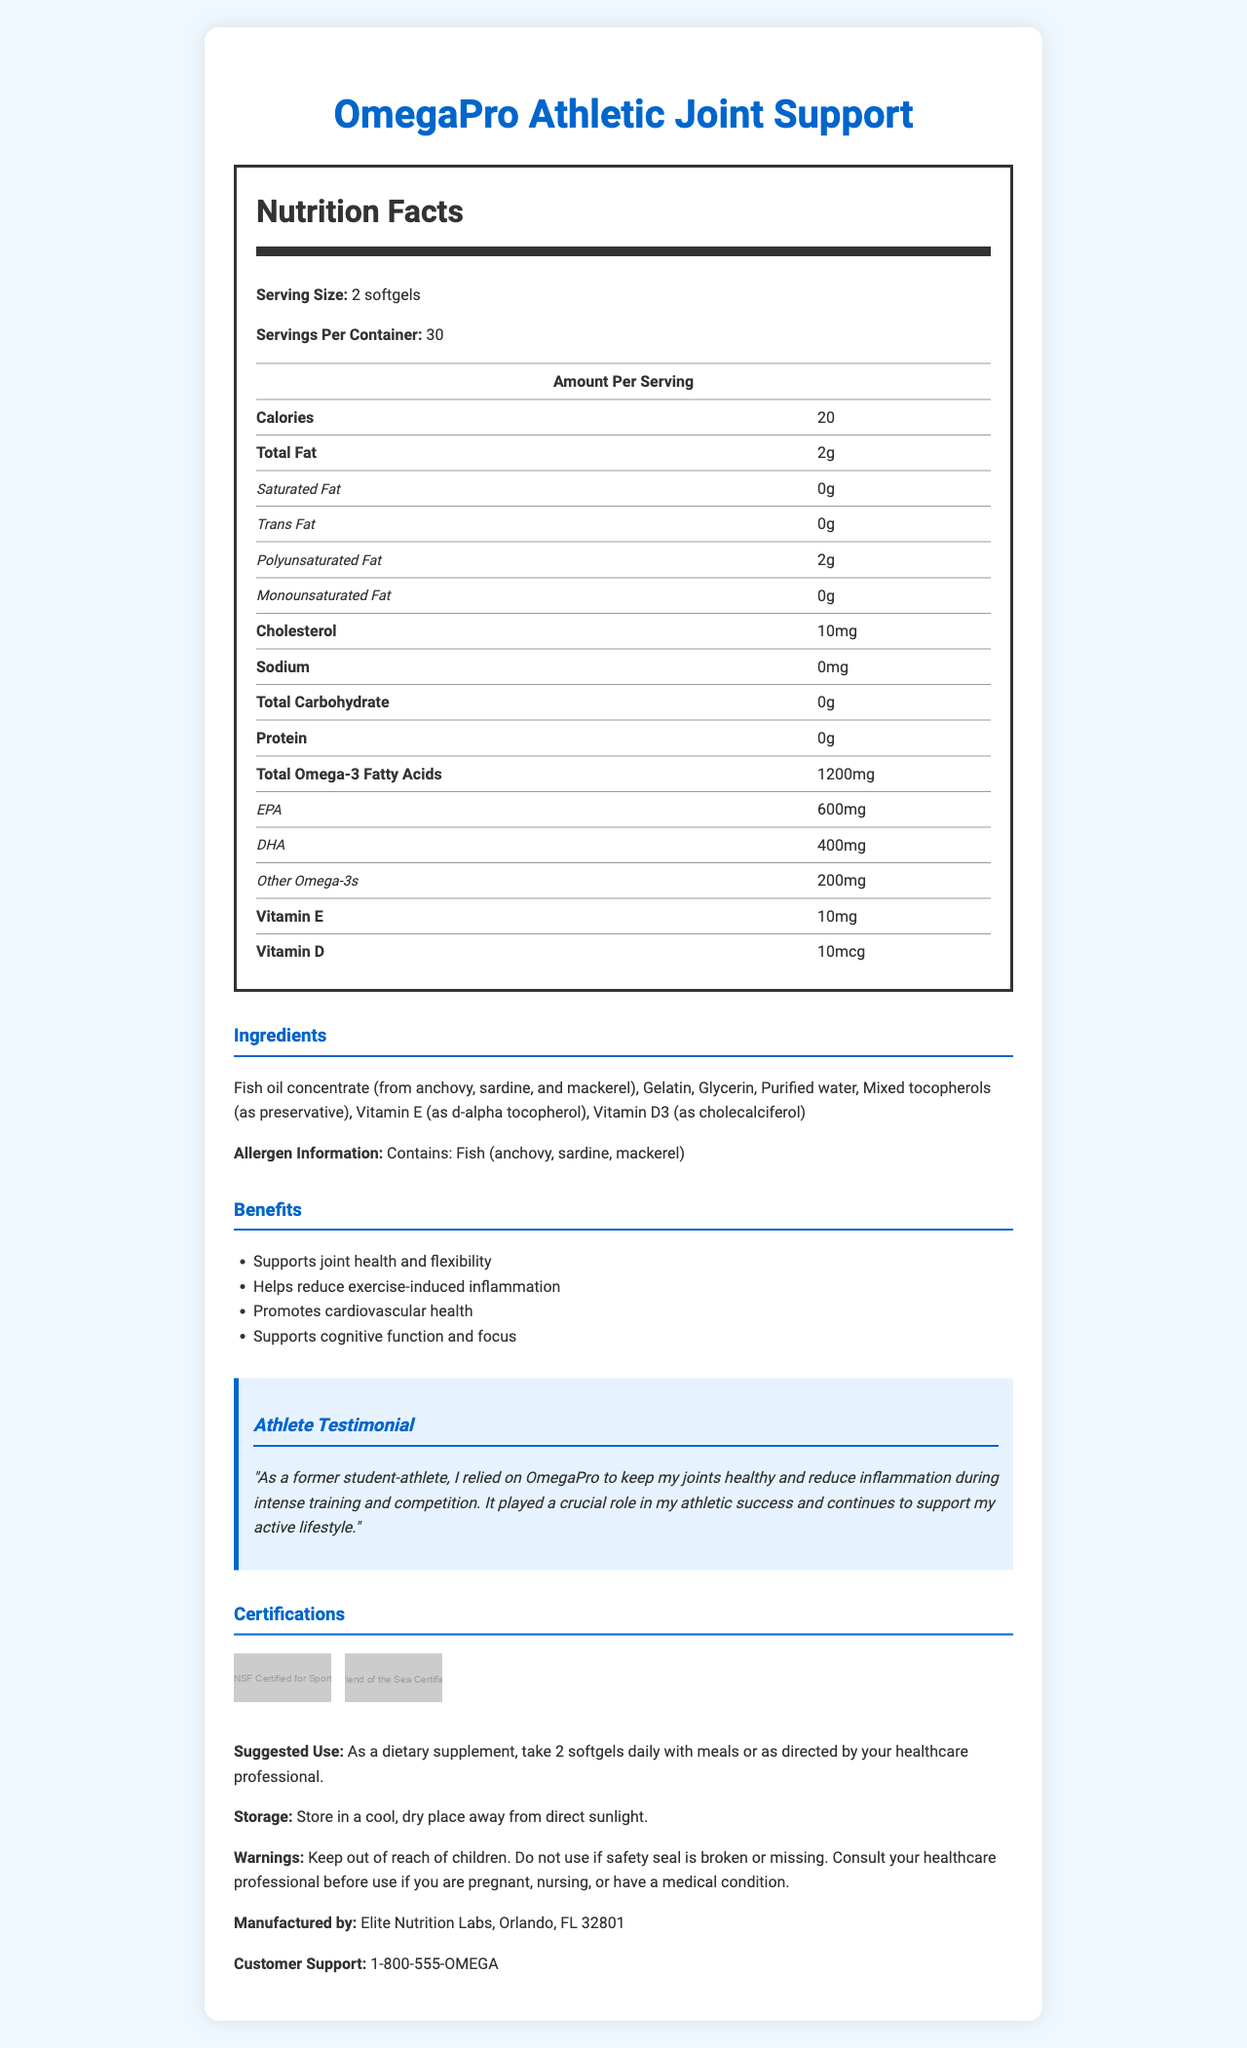who manufactures OmegaPro Athletic Joint Support? The document states that OmegaPro Athletic Joint Support is manufactured by Elite Nutrition Labs in Orlando, FL.
Answer: Elite Nutrition Labs what is the serving size for OmegaPro Athletic Joint Support? The serving size is mentioned as 2 softgels in the document.
Answer: 2 softgels how many calories are in one serving? The document states that each serving of 2 softgels contains 20 calories.
Answer: 20 what is the total omega-3 fatty acid content per serving? The total omega-3 fatty acid content per serving is listed as 1200mg in the document.
Answer: 1200mg which vitamins are included in the supplement? The document lists Vitamin E (10mg) and Vitamin D (10mcg) as part of the supplement.
Answer: Vitamin E and Vitamin D what are the main sources of fish oil in this product? A. Salmon and tuna B. Anchovy, sardine, and mackerel C. Cod and haddock The ingredients list indicates that the fish oil concentrate comes from anchovy, sardine, and mackerel.
Answer: B. Anchovy, sardine, and mackerel how much DHA is in one serving? A. 200mg B. 400mg C. 600mg The DHA content per serving is mentioned as 400mg in the document.
Answer: B. 400mg is there any cholesterol in the supplement? The document states that there is 10mg of cholesterol per serving.
Answer: Yes can this product be used by someone with a fish allergy? The allergen information clearly states that the product contains fish (anchovy, sardine, mackerel).
Answer: No does the supplement include any sodium? The document specifies that there is 0mg of sodium in the supplement.
Answer: No what is the main testimonial about the product? The testimonial section reveals that a former student-athlete credited OmegaPro with helping to maintain joint health and reduce inflammation.
Answer: A former student-athlete used it to keep joints healthy and reduce inflammation during training and competition. summarize the main benefits of consuming OmegaPro Athletic Joint Support. The benefits section lists supporting joint health, reducing inflammation from exercise, promoting cardiovascular health, and supporting cognitive function as key advantages of this supplement.
Answer: OmegaPro Athletic Joint Support aims to support joint health and flexibility, reduce exercise-induced inflammation, promote cardiovascular health, and enhance cognitive function and focus. what is the toll-free customer support number for this product? The document lists the customer support number as 1-800-555-OMEGA for any inquiries.
Answer: 1-800-555-OMEGA what are the storage recommendations for OmegaPro Athletic Joint Support? The storage instructions advise keeping the product in a cool, dry place away from direct sunlight.
Answer: Store in a cool, dry place away from direct sunlight. how many softgels are in one container? The serving size is 2 softgels and there are 30 servings per container, which means there are 60 softgels per container.
Answer: 60 softgels when should you consult your healthcare professional before using this product? The warnings section advises consulting a healthcare professional if you are pregnant, nursing, or have a medical condition.
Answer: If you are pregnant, nursing, or have a medical condition. is this product certified for sport by any entities? The document mentions the product is NSF Certified for Sport and Friend of the Sea Certified.
Answer: Yes what preservatives are used in the supplement? The document lists mixed tocopherols as a preservative in the ingredient list.
Answer: Mixed tocopherols how much polyunsaturated fat is in each serving? The nutritional facts indicate that there are 2g of polyunsaturated fat per serving.
Answer: 2g how much total carbohydrate does each serving contain? The document states that there are 0g of total carbohydrates per serving.
Answer: 0g what role did the supplement play in the testimonial provider's achievements? The athlete testimonial section highlights that the supplement was crucial in maintaining joint health and reducing inflammation, which supported the provider's athletic success.
Answer: It helped keep joints healthy and reduce inflammation during training and competition. does the document mention where the product was manufactured? The document states it was manufactured by Elite Nutrition Labs in Orlando, FL 32801.
Answer: Yes can the product packaging be recycled? The document does not mention whether the packaging is recyclable or not.
Answer: Not enough information 